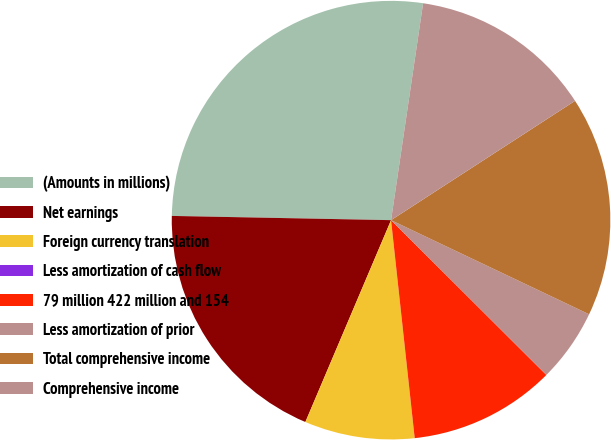Convert chart to OTSL. <chart><loc_0><loc_0><loc_500><loc_500><pie_chart><fcel>(Amounts in millions)<fcel>Net earnings<fcel>Foreign currency translation<fcel>Less amortization of cash flow<fcel>79 million 422 million and 154<fcel>Less amortization of prior<fcel>Total comprehensive income<fcel>Comprehensive income<nl><fcel>27.03%<fcel>18.92%<fcel>8.11%<fcel>0.0%<fcel>10.81%<fcel>5.41%<fcel>16.22%<fcel>13.51%<nl></chart> 